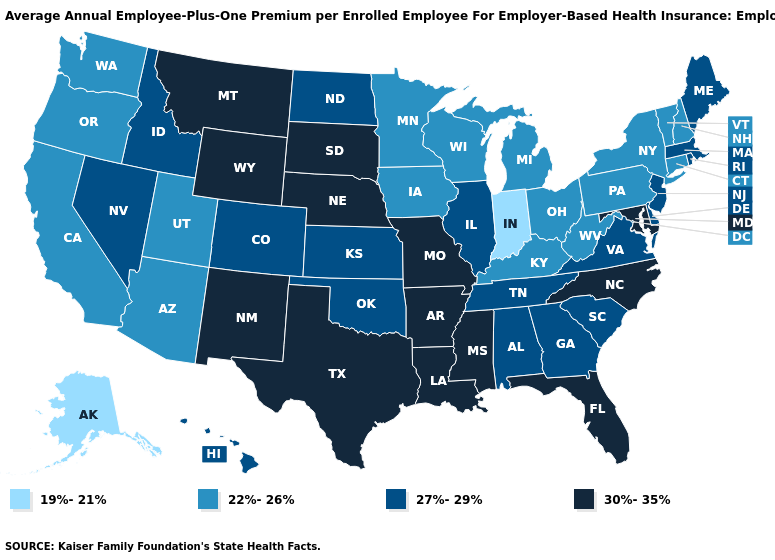Among the states that border Pennsylvania , which have the lowest value?
Give a very brief answer. New York, Ohio, West Virginia. How many symbols are there in the legend?
Short answer required. 4. What is the lowest value in states that border Kansas?
Keep it brief. 27%-29%. Name the states that have a value in the range 30%-35%?
Give a very brief answer. Arkansas, Florida, Louisiana, Maryland, Mississippi, Missouri, Montana, Nebraska, New Mexico, North Carolina, South Dakota, Texas, Wyoming. What is the highest value in the USA?
Answer briefly. 30%-35%. What is the lowest value in states that border Utah?
Keep it brief. 22%-26%. What is the value of South Dakota?
Keep it brief. 30%-35%. Does Vermont have a lower value than Alaska?
Quick response, please. No. What is the value of Illinois?
Keep it brief. 27%-29%. Which states hav the highest value in the West?
Concise answer only. Montana, New Mexico, Wyoming. What is the value of Nebraska?
Be succinct. 30%-35%. Name the states that have a value in the range 30%-35%?
Give a very brief answer. Arkansas, Florida, Louisiana, Maryland, Mississippi, Missouri, Montana, Nebraska, New Mexico, North Carolina, South Dakota, Texas, Wyoming. Does Maryland have the same value as North Carolina?
Keep it brief. Yes. What is the value of Montana?
Quick response, please. 30%-35%. What is the highest value in states that border Indiana?
Keep it brief. 27%-29%. 